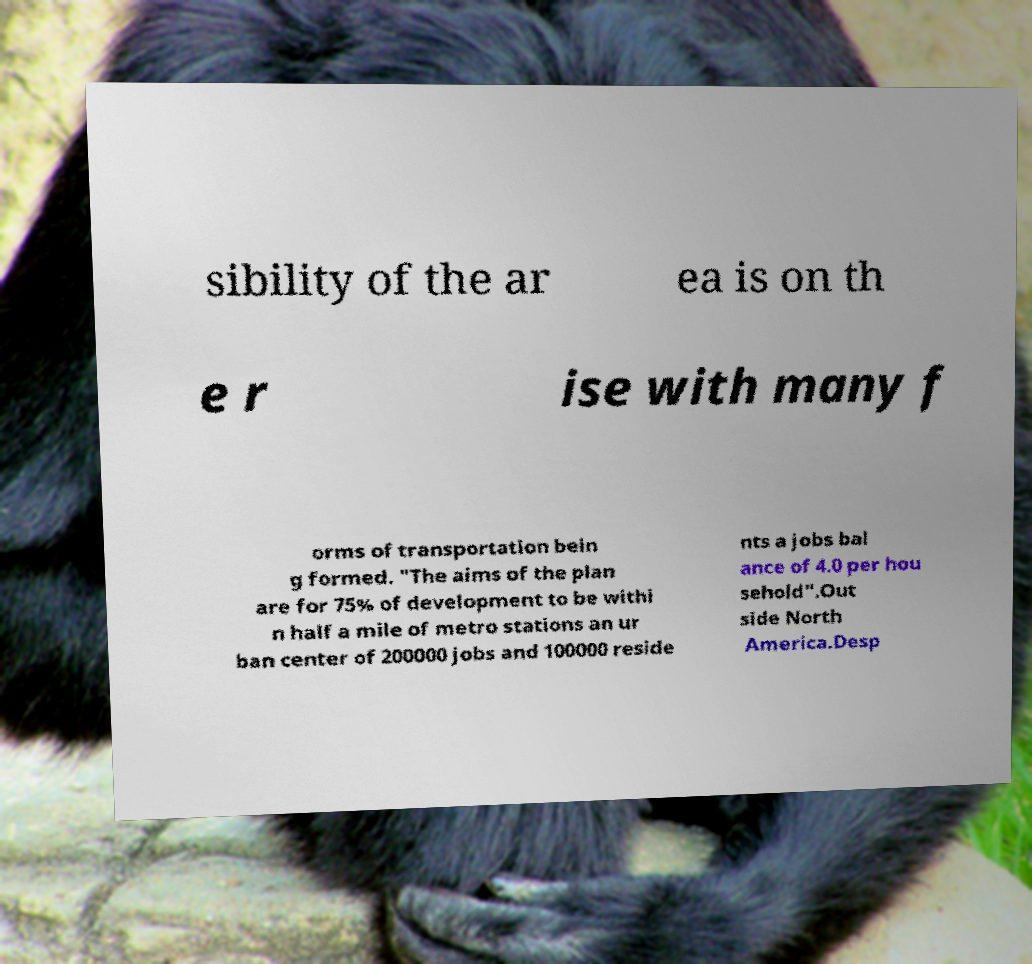Could you extract and type out the text from this image? sibility of the ar ea is on th e r ise with many f orms of transportation bein g formed. "The aims of the plan are for 75% of development to be withi n half a mile of metro stations an ur ban center of 200000 jobs and 100000 reside nts a jobs bal ance of 4.0 per hou sehold".Out side North America.Desp 